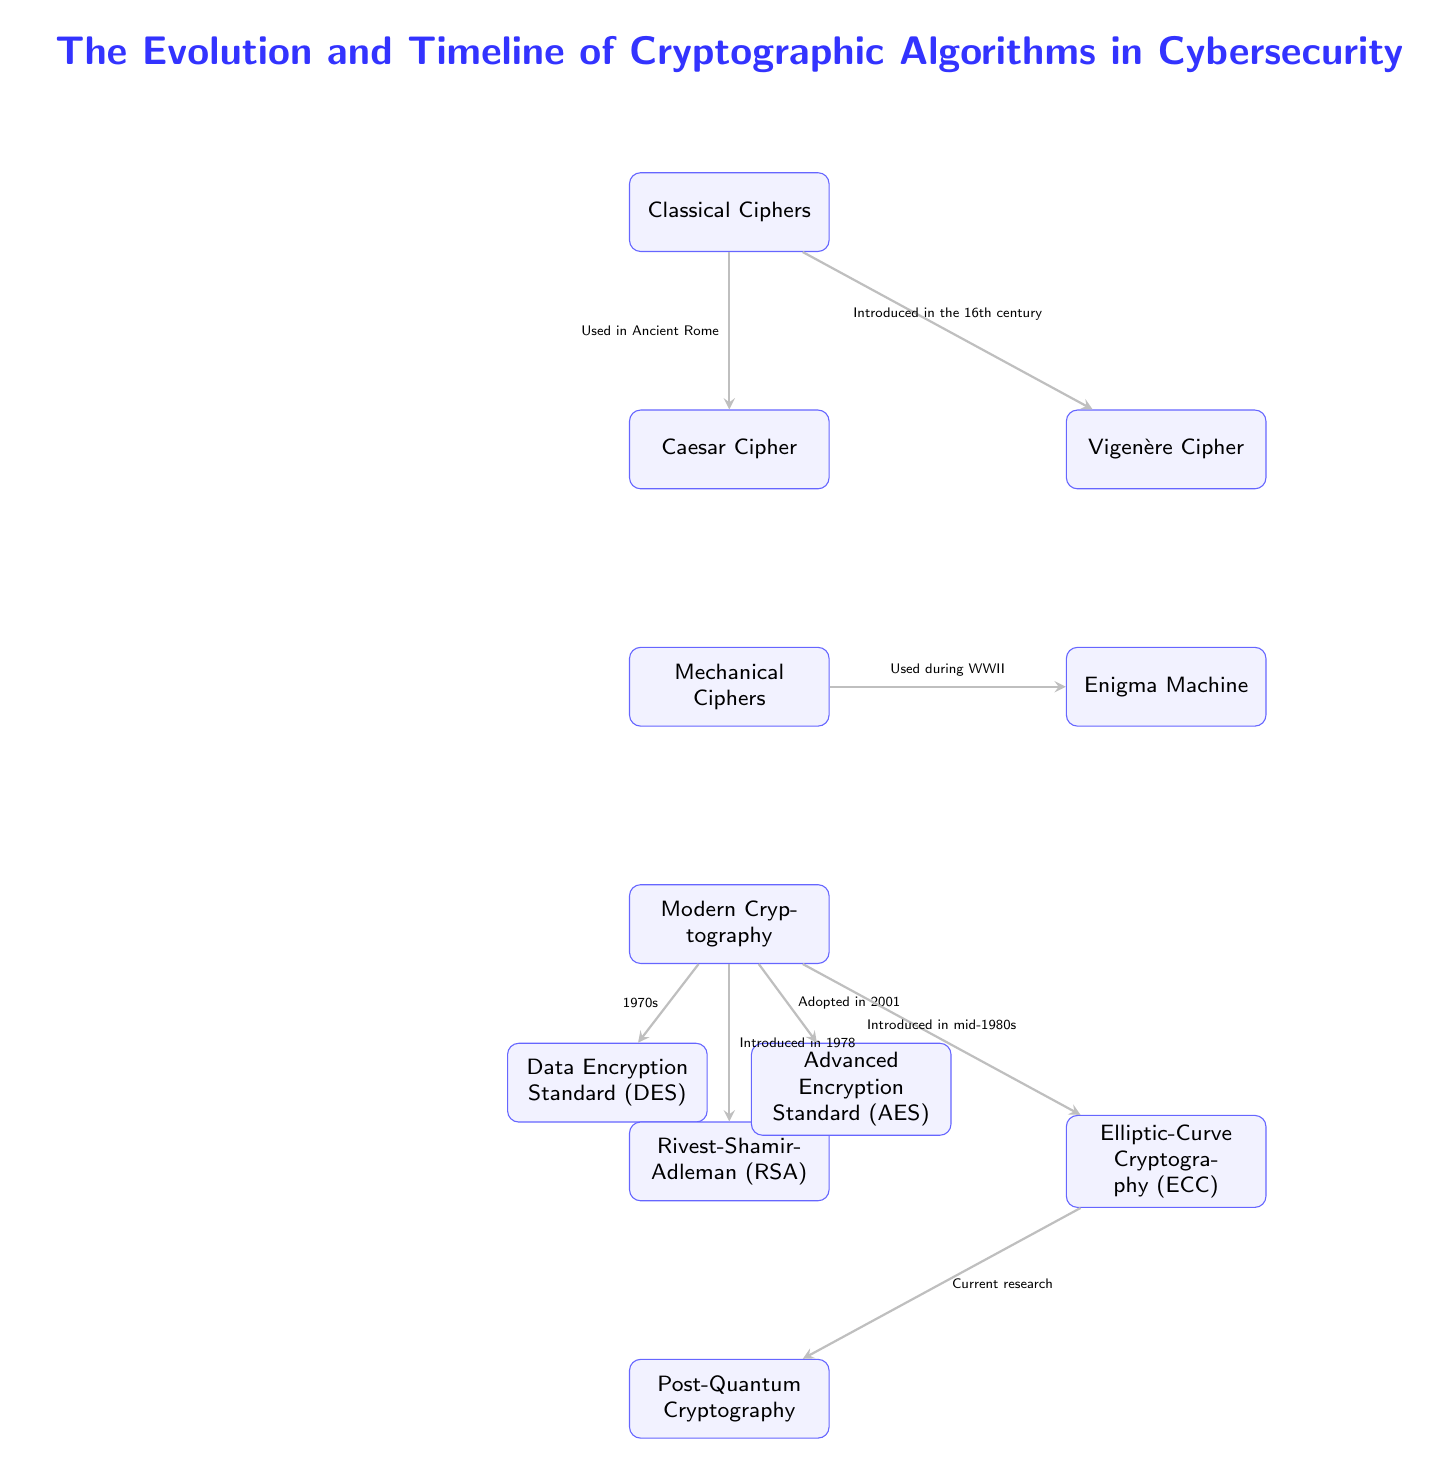What is the first type of cipher listed in the diagram? The diagram starts with the node labeled “Classical Ciphers,” which is the first node at the top.
Answer: Classical Ciphers Which cipher was used in Ancient Rome? The arrow labeled “Used in Ancient Rome” points from the “Classical Ciphers” node to the “Caesar Cipher” node, indicating that the Caesar Cipher was the specific cipher linked to Ancient Rome.
Answer: Caesar Cipher How many modern cryptographic algorithms are shown in the diagram? The "Modern Cryptography" node has three algorithms listed below it: DES, RSA, and AES, plus ECC and Post-Quantum Cryptography leading to a total of five modern algorithms.
Answer: Five Which cipher was introduced in 1978? The arrow pointing to the “Rivest-Shamir-Adleman (RSA)” node states “Introduced in 1978,” which identifies RSA as the cipher introduced in that year.
Answer: Rivest-Shamir-Adleman (RSA) What is the timeline connection from modern cryptography to Post-Quantum Cryptography? The arrow from the “Elliptic-Curve Cryptography (ECC)” node points to the “Post-Quantum Cryptography” node, indicating that Post-Quantum Cryptography is current research following ECC.
Answer: Current research What type of ciphers were used during WWII? The diagram cites the “Mechanical Ciphers” node, which connects to the “Enigma Machine” node, indicating that the Enigma Machine is a type of mechanical cipher used during WWII.
Answer: Mechanical Ciphers What specific cryptographic method was adopted in 2001? The diagram has an arrow from the “Modern Cryptography” node to the “Advanced Encryption Standard (AES)” node labeled “Adopted in 2001,” identifying AES as the method adopted that year.
Answer: Advanced Encryption Standard (AES) How does the Vigenère Cipher relate to Classical Ciphers? The arrow from “Classical Ciphers” points to “Vigenère Cipher,” indicating that the Vigenère Cipher is a subtype or category under Classical Ciphers, introduced in the 16th century.
Answer: Vigenère Cipher 